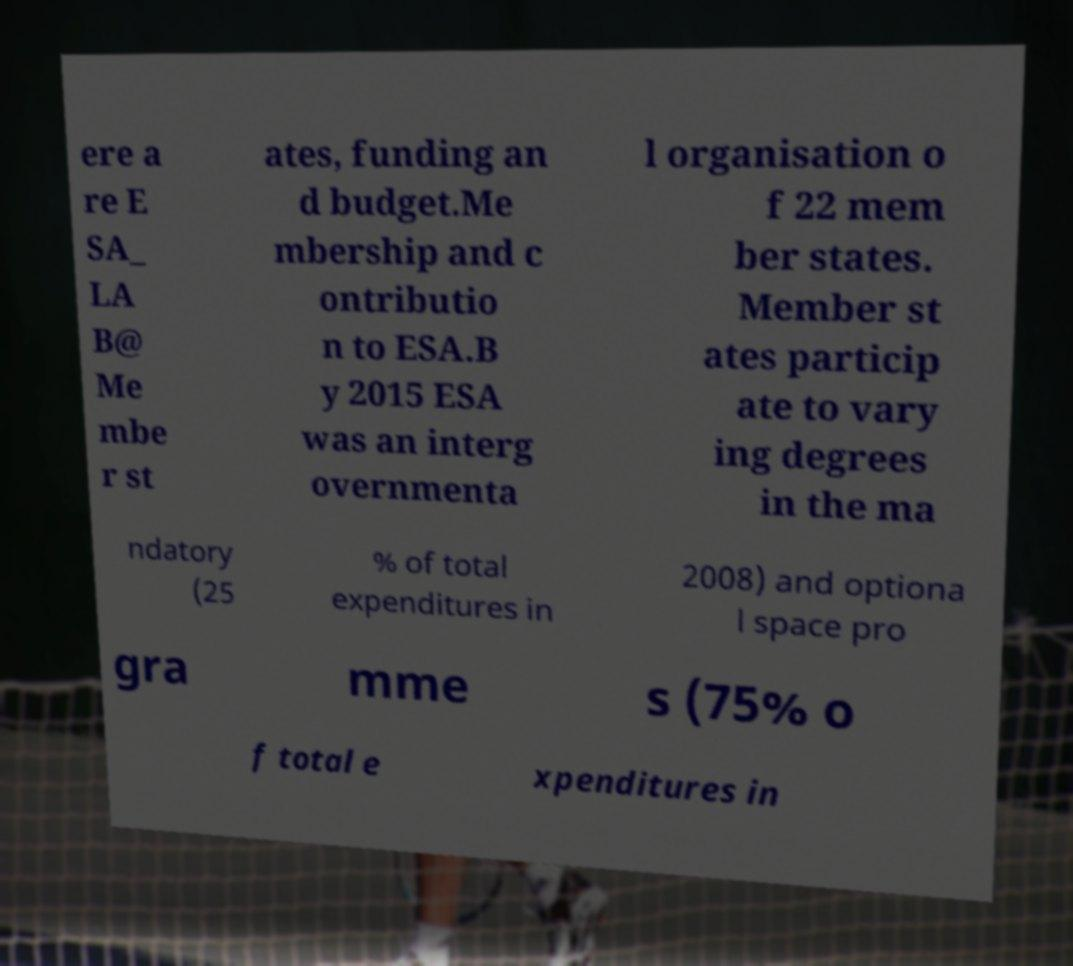Can you accurately transcribe the text from the provided image for me? ere a re E SA_ LA B@ Me mbe r st ates, funding an d budget.Me mbership and c ontributio n to ESA.B y 2015 ESA was an interg overnmenta l organisation o f 22 mem ber states. Member st ates particip ate to vary ing degrees in the ma ndatory (25 % of total expenditures in 2008) and optiona l space pro gra mme s (75% o f total e xpenditures in 